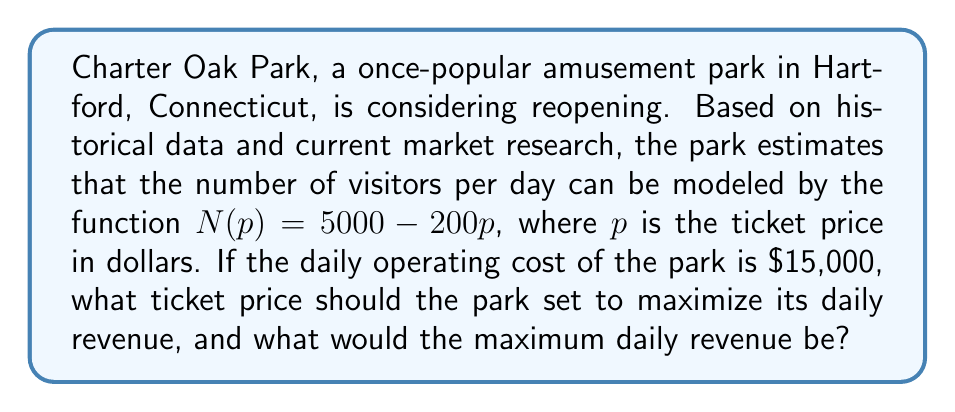Solve this math problem. Let's approach this step-by-step:

1) The revenue function $R(p)$ is the product of the number of visitors and the ticket price, minus the operating cost:

   $R(p) = p \cdot N(p) - 15000$

2) Substituting the given function for $N(p)$:

   $R(p) = p \cdot (5000 - 200p) - 15000$

3) Expanding the equation:

   $R(p) = 5000p - 200p^2 - 15000$

4) To find the maximum revenue, we need to find the vertex of this parabola. We can do this by finding where the derivative equals zero:

   $R'(p) = 5000 - 400p$

5) Set $R'(p) = 0$ and solve for $p$:

   $5000 - 400p = 0$
   $-400p = -5000$
   $p = 12.5$

6) This critical point will give us the maximum revenue since the parabola opens downward (the coefficient of $p^2$ is negative).

7) To find the maximum revenue, we plug $p = 12.5$ back into our revenue function:

   $R(12.5) = 5000(12.5) - 200(12.5)^2 - 15000$
            $= 62500 - 31250 - 15000$
            $= 16250$

Therefore, the park should set the ticket price to $12.50, which will result in a maximum daily revenue of $16,250.
Answer: Ticket price: $12.50; Maximum daily revenue: $16,250 